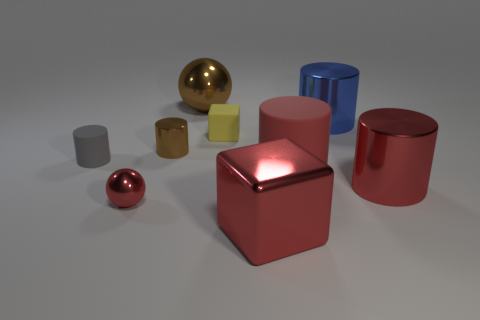Subtract all large red rubber cylinders. How many cylinders are left? 4 Subtract all gray cylinders. How many cylinders are left? 4 Subtract all green cylinders. Subtract all red cubes. How many cylinders are left? 5 Add 1 shiny objects. How many objects exist? 10 Subtract all cylinders. How many objects are left? 4 Add 5 small rubber cylinders. How many small rubber cylinders are left? 6 Add 9 small blue matte cylinders. How many small blue matte cylinders exist? 9 Subtract 0 cyan cubes. How many objects are left? 9 Subtract all green matte things. Subtract all big blue metal things. How many objects are left? 8 